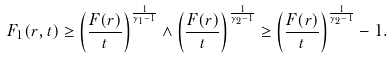<formula> <loc_0><loc_0><loc_500><loc_500>F _ { 1 } ( r , t ) \geq \left ( \frac { F ( r ) } { t } \right ) ^ { \frac { 1 } { \gamma _ { 1 } - 1 } } \wedge \left ( \frac { F ( r ) } { t } \right ) ^ { \frac { 1 } { \gamma _ { 2 } - 1 } } \geq \left ( \frac { F ( r ) } { t } \right ) ^ { \frac { 1 } { \gamma _ { 2 } - 1 } } - 1 .</formula> 